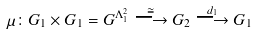Convert formula to latex. <formula><loc_0><loc_0><loc_500><loc_500>\mu \colon G _ { 1 } \times G _ { 1 } = G ^ { \Lambda ^ { 2 } _ { 1 } } \stackrel { \cong } { \longrightarrow } G _ { 2 } \stackrel { d _ { 1 } } { \longrightarrow } G _ { 1 }</formula> 